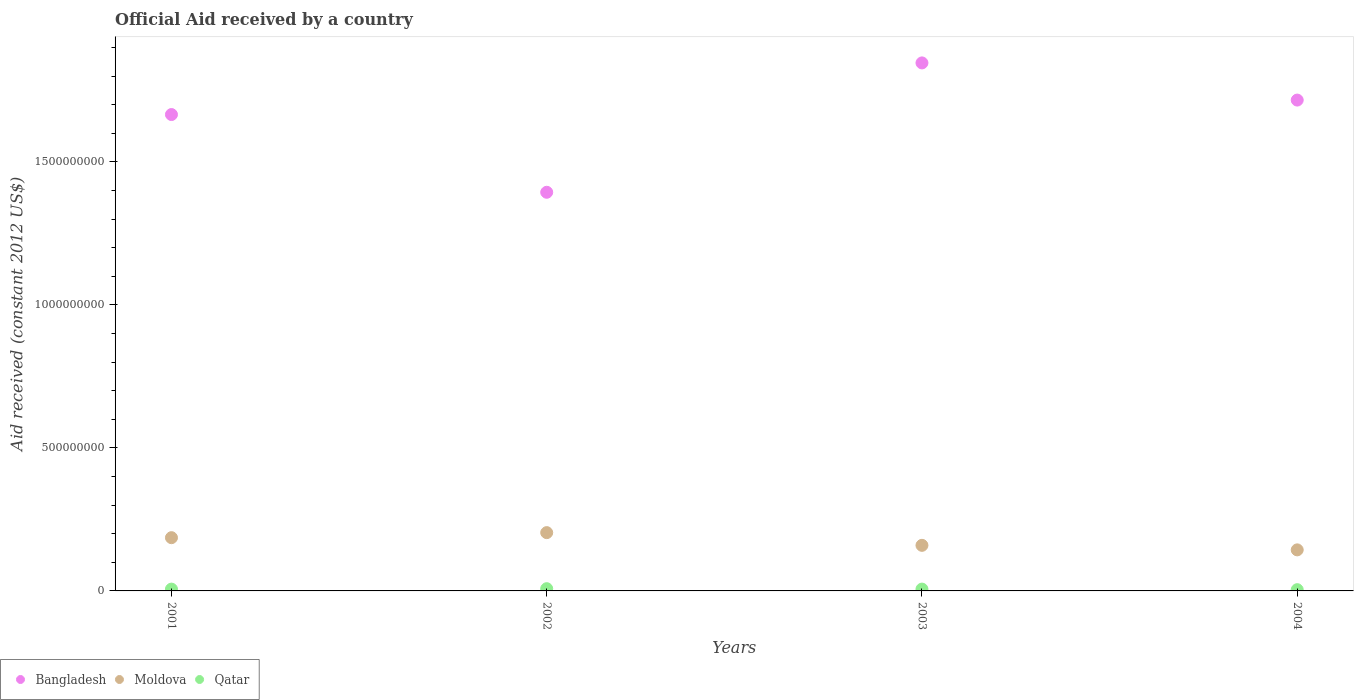What is the net official aid received in Moldova in 2003?
Offer a terse response. 1.59e+08. Across all years, what is the maximum net official aid received in Bangladesh?
Keep it short and to the point. 1.85e+09. Across all years, what is the minimum net official aid received in Moldova?
Ensure brevity in your answer.  1.44e+08. In which year was the net official aid received in Moldova maximum?
Make the answer very short. 2002. In which year was the net official aid received in Bangladesh minimum?
Provide a succinct answer. 2002. What is the total net official aid received in Bangladesh in the graph?
Offer a very short reply. 6.62e+09. What is the difference between the net official aid received in Bangladesh in 2003 and that in 2004?
Your answer should be compact. 1.30e+08. What is the difference between the net official aid received in Bangladesh in 2002 and the net official aid received in Qatar in 2003?
Give a very brief answer. 1.39e+09. What is the average net official aid received in Moldova per year?
Ensure brevity in your answer.  1.73e+08. In the year 2001, what is the difference between the net official aid received in Moldova and net official aid received in Bangladesh?
Provide a succinct answer. -1.48e+09. What is the ratio of the net official aid received in Moldova in 2001 to that in 2003?
Offer a terse response. 1.17. Is the net official aid received in Moldova in 2001 less than that in 2003?
Your response must be concise. No. Is the difference between the net official aid received in Moldova in 2002 and 2004 greater than the difference between the net official aid received in Bangladesh in 2002 and 2004?
Give a very brief answer. Yes. What is the difference between the highest and the second highest net official aid received in Moldova?
Ensure brevity in your answer.  1.77e+07. What is the difference between the highest and the lowest net official aid received in Moldova?
Offer a terse response. 6.03e+07. In how many years, is the net official aid received in Bangladesh greater than the average net official aid received in Bangladesh taken over all years?
Make the answer very short. 3. Is it the case that in every year, the sum of the net official aid received in Qatar and net official aid received in Bangladesh  is greater than the net official aid received in Moldova?
Your response must be concise. Yes. Does the net official aid received in Bangladesh monotonically increase over the years?
Make the answer very short. No. Is the net official aid received in Qatar strictly greater than the net official aid received in Bangladesh over the years?
Your response must be concise. No. Is the net official aid received in Qatar strictly less than the net official aid received in Moldova over the years?
Provide a short and direct response. Yes. Are the values on the major ticks of Y-axis written in scientific E-notation?
Make the answer very short. No. Does the graph contain grids?
Offer a terse response. No. How many legend labels are there?
Ensure brevity in your answer.  3. What is the title of the graph?
Keep it short and to the point. Official Aid received by a country. Does "Aruba" appear as one of the legend labels in the graph?
Offer a very short reply. No. What is the label or title of the X-axis?
Your answer should be compact. Years. What is the label or title of the Y-axis?
Ensure brevity in your answer.  Aid received (constant 2012 US$). What is the Aid received (constant 2012 US$) of Bangladesh in 2001?
Give a very brief answer. 1.67e+09. What is the Aid received (constant 2012 US$) of Moldova in 2001?
Offer a terse response. 1.86e+08. What is the Aid received (constant 2012 US$) of Qatar in 2001?
Ensure brevity in your answer.  6.30e+06. What is the Aid received (constant 2012 US$) in Bangladesh in 2002?
Keep it short and to the point. 1.39e+09. What is the Aid received (constant 2012 US$) in Moldova in 2002?
Provide a short and direct response. 2.04e+08. What is the Aid received (constant 2012 US$) of Qatar in 2002?
Keep it short and to the point. 7.79e+06. What is the Aid received (constant 2012 US$) of Bangladesh in 2003?
Make the answer very short. 1.85e+09. What is the Aid received (constant 2012 US$) of Moldova in 2003?
Provide a succinct answer. 1.59e+08. What is the Aid received (constant 2012 US$) in Qatar in 2003?
Make the answer very short. 6.38e+06. What is the Aid received (constant 2012 US$) of Bangladesh in 2004?
Provide a short and direct response. 1.72e+09. What is the Aid received (constant 2012 US$) in Moldova in 2004?
Provide a succinct answer. 1.44e+08. What is the Aid received (constant 2012 US$) of Qatar in 2004?
Ensure brevity in your answer.  4.35e+06. Across all years, what is the maximum Aid received (constant 2012 US$) of Bangladesh?
Give a very brief answer. 1.85e+09. Across all years, what is the maximum Aid received (constant 2012 US$) in Moldova?
Your response must be concise. 2.04e+08. Across all years, what is the maximum Aid received (constant 2012 US$) of Qatar?
Your answer should be very brief. 7.79e+06. Across all years, what is the minimum Aid received (constant 2012 US$) in Bangladesh?
Ensure brevity in your answer.  1.39e+09. Across all years, what is the minimum Aid received (constant 2012 US$) in Moldova?
Give a very brief answer. 1.44e+08. Across all years, what is the minimum Aid received (constant 2012 US$) of Qatar?
Offer a terse response. 4.35e+06. What is the total Aid received (constant 2012 US$) of Bangladesh in the graph?
Offer a terse response. 6.62e+09. What is the total Aid received (constant 2012 US$) in Moldova in the graph?
Your answer should be compact. 6.93e+08. What is the total Aid received (constant 2012 US$) of Qatar in the graph?
Provide a succinct answer. 2.48e+07. What is the difference between the Aid received (constant 2012 US$) of Bangladesh in 2001 and that in 2002?
Give a very brief answer. 2.72e+08. What is the difference between the Aid received (constant 2012 US$) in Moldova in 2001 and that in 2002?
Offer a terse response. -1.77e+07. What is the difference between the Aid received (constant 2012 US$) in Qatar in 2001 and that in 2002?
Ensure brevity in your answer.  -1.49e+06. What is the difference between the Aid received (constant 2012 US$) of Bangladesh in 2001 and that in 2003?
Offer a terse response. -1.81e+08. What is the difference between the Aid received (constant 2012 US$) in Moldova in 2001 and that in 2003?
Offer a very short reply. 2.68e+07. What is the difference between the Aid received (constant 2012 US$) in Bangladesh in 2001 and that in 2004?
Offer a very short reply. -5.06e+07. What is the difference between the Aid received (constant 2012 US$) in Moldova in 2001 and that in 2004?
Offer a terse response. 4.26e+07. What is the difference between the Aid received (constant 2012 US$) in Qatar in 2001 and that in 2004?
Your response must be concise. 1.95e+06. What is the difference between the Aid received (constant 2012 US$) of Bangladesh in 2002 and that in 2003?
Ensure brevity in your answer.  -4.52e+08. What is the difference between the Aid received (constant 2012 US$) of Moldova in 2002 and that in 2003?
Give a very brief answer. 4.44e+07. What is the difference between the Aid received (constant 2012 US$) of Qatar in 2002 and that in 2003?
Ensure brevity in your answer.  1.41e+06. What is the difference between the Aid received (constant 2012 US$) of Bangladesh in 2002 and that in 2004?
Provide a succinct answer. -3.22e+08. What is the difference between the Aid received (constant 2012 US$) of Moldova in 2002 and that in 2004?
Offer a terse response. 6.03e+07. What is the difference between the Aid received (constant 2012 US$) in Qatar in 2002 and that in 2004?
Give a very brief answer. 3.44e+06. What is the difference between the Aid received (constant 2012 US$) of Bangladesh in 2003 and that in 2004?
Provide a short and direct response. 1.30e+08. What is the difference between the Aid received (constant 2012 US$) of Moldova in 2003 and that in 2004?
Your response must be concise. 1.58e+07. What is the difference between the Aid received (constant 2012 US$) in Qatar in 2003 and that in 2004?
Provide a succinct answer. 2.03e+06. What is the difference between the Aid received (constant 2012 US$) in Bangladesh in 2001 and the Aid received (constant 2012 US$) in Moldova in 2002?
Ensure brevity in your answer.  1.46e+09. What is the difference between the Aid received (constant 2012 US$) of Bangladesh in 2001 and the Aid received (constant 2012 US$) of Qatar in 2002?
Provide a succinct answer. 1.66e+09. What is the difference between the Aid received (constant 2012 US$) in Moldova in 2001 and the Aid received (constant 2012 US$) in Qatar in 2002?
Make the answer very short. 1.78e+08. What is the difference between the Aid received (constant 2012 US$) of Bangladesh in 2001 and the Aid received (constant 2012 US$) of Moldova in 2003?
Keep it short and to the point. 1.51e+09. What is the difference between the Aid received (constant 2012 US$) of Bangladesh in 2001 and the Aid received (constant 2012 US$) of Qatar in 2003?
Give a very brief answer. 1.66e+09. What is the difference between the Aid received (constant 2012 US$) in Moldova in 2001 and the Aid received (constant 2012 US$) in Qatar in 2003?
Keep it short and to the point. 1.80e+08. What is the difference between the Aid received (constant 2012 US$) of Bangladesh in 2001 and the Aid received (constant 2012 US$) of Moldova in 2004?
Ensure brevity in your answer.  1.52e+09. What is the difference between the Aid received (constant 2012 US$) of Bangladesh in 2001 and the Aid received (constant 2012 US$) of Qatar in 2004?
Ensure brevity in your answer.  1.66e+09. What is the difference between the Aid received (constant 2012 US$) of Moldova in 2001 and the Aid received (constant 2012 US$) of Qatar in 2004?
Keep it short and to the point. 1.82e+08. What is the difference between the Aid received (constant 2012 US$) of Bangladesh in 2002 and the Aid received (constant 2012 US$) of Moldova in 2003?
Your answer should be very brief. 1.23e+09. What is the difference between the Aid received (constant 2012 US$) of Bangladesh in 2002 and the Aid received (constant 2012 US$) of Qatar in 2003?
Give a very brief answer. 1.39e+09. What is the difference between the Aid received (constant 2012 US$) in Moldova in 2002 and the Aid received (constant 2012 US$) in Qatar in 2003?
Offer a very short reply. 1.97e+08. What is the difference between the Aid received (constant 2012 US$) in Bangladesh in 2002 and the Aid received (constant 2012 US$) in Moldova in 2004?
Provide a short and direct response. 1.25e+09. What is the difference between the Aid received (constant 2012 US$) of Bangladesh in 2002 and the Aid received (constant 2012 US$) of Qatar in 2004?
Give a very brief answer. 1.39e+09. What is the difference between the Aid received (constant 2012 US$) of Moldova in 2002 and the Aid received (constant 2012 US$) of Qatar in 2004?
Your answer should be very brief. 2.00e+08. What is the difference between the Aid received (constant 2012 US$) in Bangladesh in 2003 and the Aid received (constant 2012 US$) in Moldova in 2004?
Your answer should be very brief. 1.70e+09. What is the difference between the Aid received (constant 2012 US$) of Bangladesh in 2003 and the Aid received (constant 2012 US$) of Qatar in 2004?
Keep it short and to the point. 1.84e+09. What is the difference between the Aid received (constant 2012 US$) in Moldova in 2003 and the Aid received (constant 2012 US$) in Qatar in 2004?
Make the answer very short. 1.55e+08. What is the average Aid received (constant 2012 US$) of Bangladesh per year?
Give a very brief answer. 1.66e+09. What is the average Aid received (constant 2012 US$) in Moldova per year?
Ensure brevity in your answer.  1.73e+08. What is the average Aid received (constant 2012 US$) of Qatar per year?
Provide a succinct answer. 6.20e+06. In the year 2001, what is the difference between the Aid received (constant 2012 US$) in Bangladesh and Aid received (constant 2012 US$) in Moldova?
Your answer should be compact. 1.48e+09. In the year 2001, what is the difference between the Aid received (constant 2012 US$) in Bangladesh and Aid received (constant 2012 US$) in Qatar?
Keep it short and to the point. 1.66e+09. In the year 2001, what is the difference between the Aid received (constant 2012 US$) of Moldova and Aid received (constant 2012 US$) of Qatar?
Ensure brevity in your answer.  1.80e+08. In the year 2002, what is the difference between the Aid received (constant 2012 US$) of Bangladesh and Aid received (constant 2012 US$) of Moldova?
Your answer should be compact. 1.19e+09. In the year 2002, what is the difference between the Aid received (constant 2012 US$) in Bangladesh and Aid received (constant 2012 US$) in Qatar?
Offer a terse response. 1.39e+09. In the year 2002, what is the difference between the Aid received (constant 2012 US$) of Moldova and Aid received (constant 2012 US$) of Qatar?
Offer a very short reply. 1.96e+08. In the year 2003, what is the difference between the Aid received (constant 2012 US$) of Bangladesh and Aid received (constant 2012 US$) of Moldova?
Provide a short and direct response. 1.69e+09. In the year 2003, what is the difference between the Aid received (constant 2012 US$) in Bangladesh and Aid received (constant 2012 US$) in Qatar?
Ensure brevity in your answer.  1.84e+09. In the year 2003, what is the difference between the Aid received (constant 2012 US$) of Moldova and Aid received (constant 2012 US$) of Qatar?
Provide a short and direct response. 1.53e+08. In the year 2004, what is the difference between the Aid received (constant 2012 US$) in Bangladesh and Aid received (constant 2012 US$) in Moldova?
Your answer should be compact. 1.57e+09. In the year 2004, what is the difference between the Aid received (constant 2012 US$) of Bangladesh and Aid received (constant 2012 US$) of Qatar?
Provide a short and direct response. 1.71e+09. In the year 2004, what is the difference between the Aid received (constant 2012 US$) in Moldova and Aid received (constant 2012 US$) in Qatar?
Offer a terse response. 1.39e+08. What is the ratio of the Aid received (constant 2012 US$) of Bangladesh in 2001 to that in 2002?
Ensure brevity in your answer.  1.2. What is the ratio of the Aid received (constant 2012 US$) in Moldova in 2001 to that in 2002?
Your response must be concise. 0.91. What is the ratio of the Aid received (constant 2012 US$) of Qatar in 2001 to that in 2002?
Provide a short and direct response. 0.81. What is the ratio of the Aid received (constant 2012 US$) of Bangladesh in 2001 to that in 2003?
Ensure brevity in your answer.  0.9. What is the ratio of the Aid received (constant 2012 US$) in Moldova in 2001 to that in 2003?
Provide a short and direct response. 1.17. What is the ratio of the Aid received (constant 2012 US$) of Qatar in 2001 to that in 2003?
Provide a succinct answer. 0.99. What is the ratio of the Aid received (constant 2012 US$) of Bangladesh in 2001 to that in 2004?
Provide a short and direct response. 0.97. What is the ratio of the Aid received (constant 2012 US$) of Moldova in 2001 to that in 2004?
Your answer should be very brief. 1.3. What is the ratio of the Aid received (constant 2012 US$) of Qatar in 2001 to that in 2004?
Provide a succinct answer. 1.45. What is the ratio of the Aid received (constant 2012 US$) of Bangladesh in 2002 to that in 2003?
Make the answer very short. 0.76. What is the ratio of the Aid received (constant 2012 US$) in Moldova in 2002 to that in 2003?
Make the answer very short. 1.28. What is the ratio of the Aid received (constant 2012 US$) in Qatar in 2002 to that in 2003?
Your response must be concise. 1.22. What is the ratio of the Aid received (constant 2012 US$) of Bangladesh in 2002 to that in 2004?
Offer a very short reply. 0.81. What is the ratio of the Aid received (constant 2012 US$) in Moldova in 2002 to that in 2004?
Your answer should be very brief. 1.42. What is the ratio of the Aid received (constant 2012 US$) in Qatar in 2002 to that in 2004?
Ensure brevity in your answer.  1.79. What is the ratio of the Aid received (constant 2012 US$) in Bangladesh in 2003 to that in 2004?
Provide a short and direct response. 1.08. What is the ratio of the Aid received (constant 2012 US$) of Moldova in 2003 to that in 2004?
Give a very brief answer. 1.11. What is the ratio of the Aid received (constant 2012 US$) of Qatar in 2003 to that in 2004?
Ensure brevity in your answer.  1.47. What is the difference between the highest and the second highest Aid received (constant 2012 US$) in Bangladesh?
Keep it short and to the point. 1.30e+08. What is the difference between the highest and the second highest Aid received (constant 2012 US$) of Moldova?
Your answer should be very brief. 1.77e+07. What is the difference between the highest and the second highest Aid received (constant 2012 US$) of Qatar?
Make the answer very short. 1.41e+06. What is the difference between the highest and the lowest Aid received (constant 2012 US$) of Bangladesh?
Ensure brevity in your answer.  4.52e+08. What is the difference between the highest and the lowest Aid received (constant 2012 US$) in Moldova?
Give a very brief answer. 6.03e+07. What is the difference between the highest and the lowest Aid received (constant 2012 US$) in Qatar?
Your answer should be very brief. 3.44e+06. 